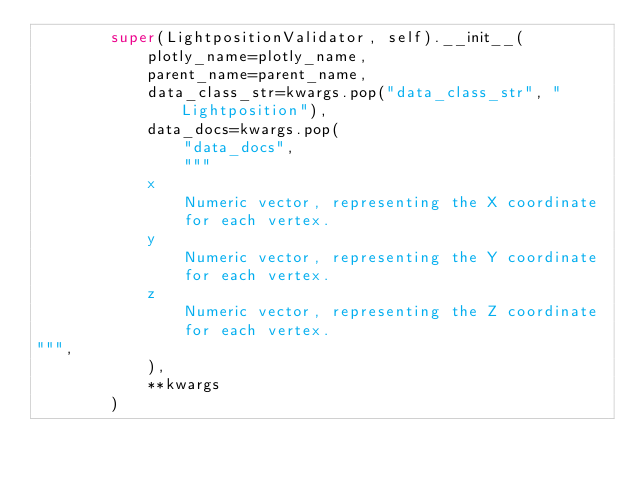<code> <loc_0><loc_0><loc_500><loc_500><_Python_>        super(LightpositionValidator, self).__init__(
            plotly_name=plotly_name,
            parent_name=parent_name,
            data_class_str=kwargs.pop("data_class_str", "Lightposition"),
            data_docs=kwargs.pop(
                "data_docs",
                """
            x
                Numeric vector, representing the X coordinate
                for each vertex.
            y
                Numeric vector, representing the Y coordinate
                for each vertex.
            z
                Numeric vector, representing the Z coordinate
                for each vertex.
""",
            ),
            **kwargs
        )
</code> 